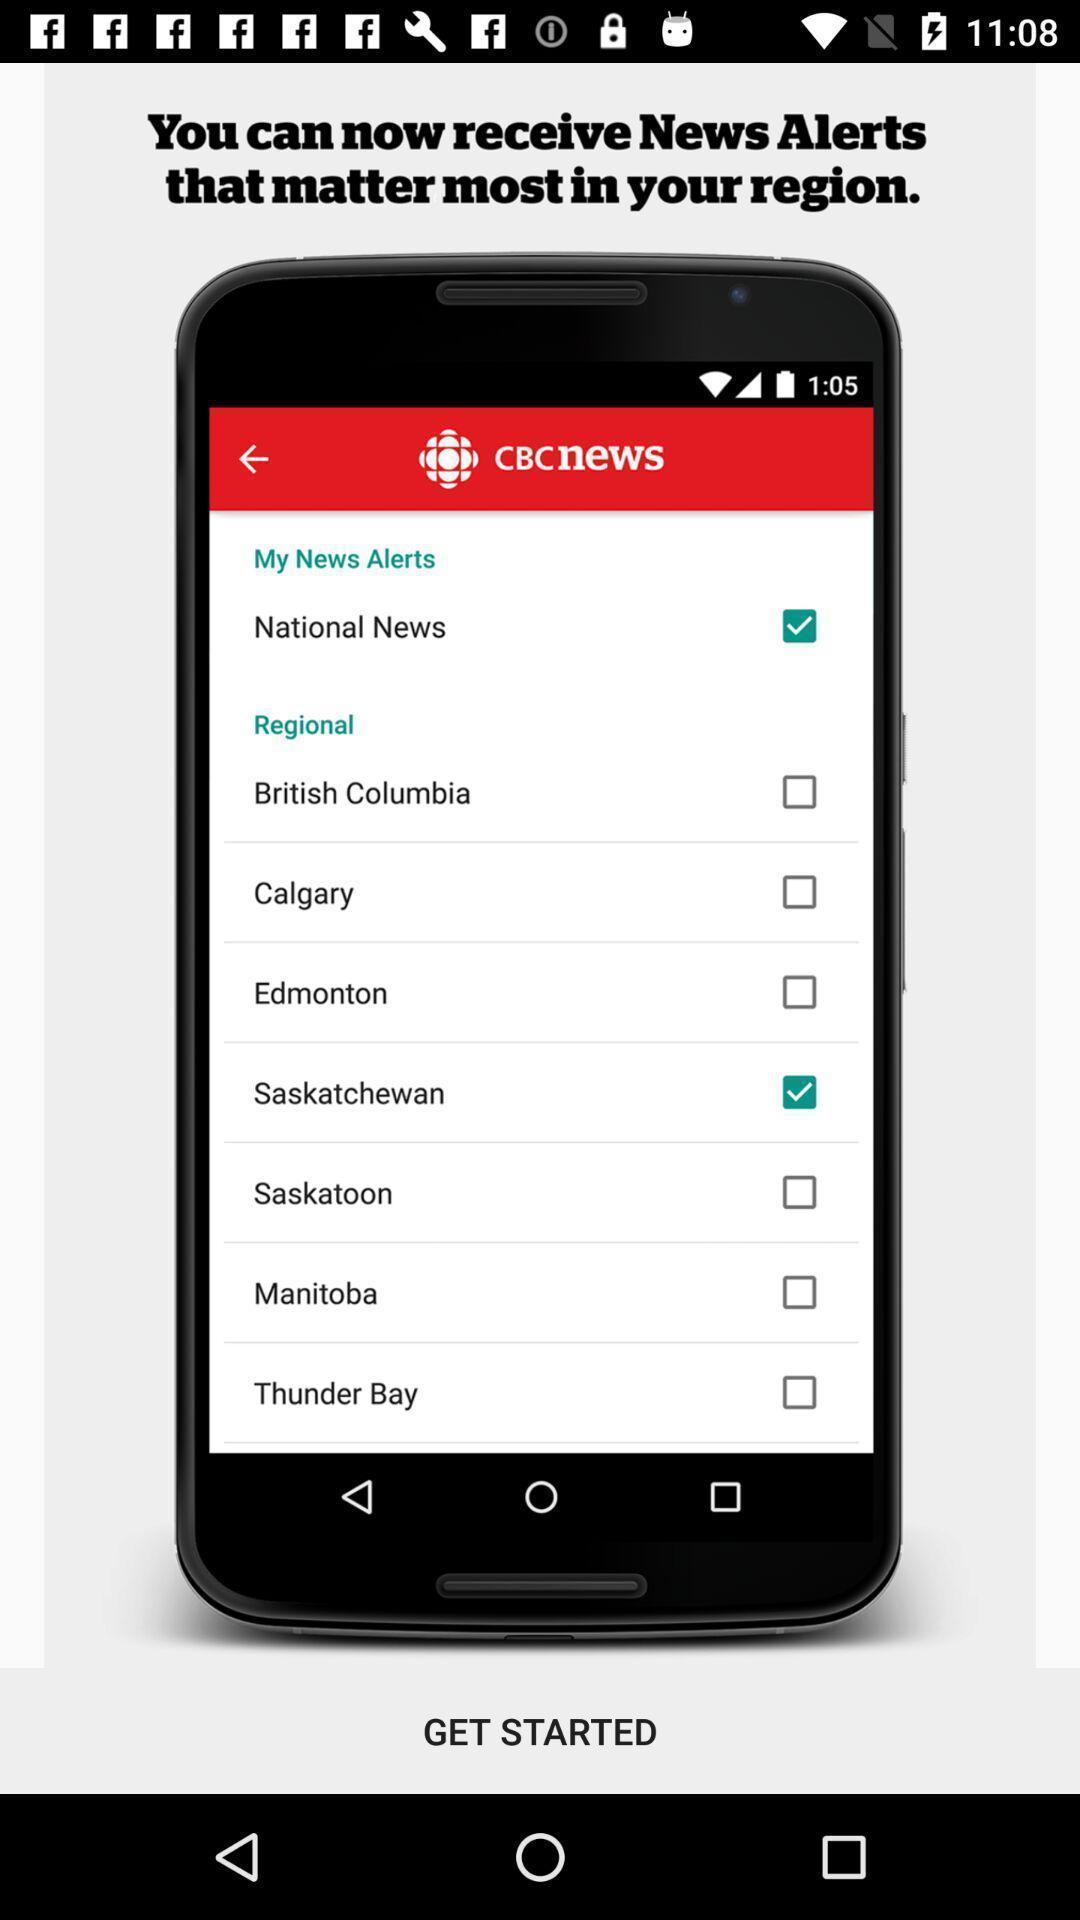Provide a textual representation of this image. Welcome page. 